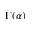<formula> <loc_0><loc_0><loc_500><loc_500>\Gamma ( \alpha )</formula> 